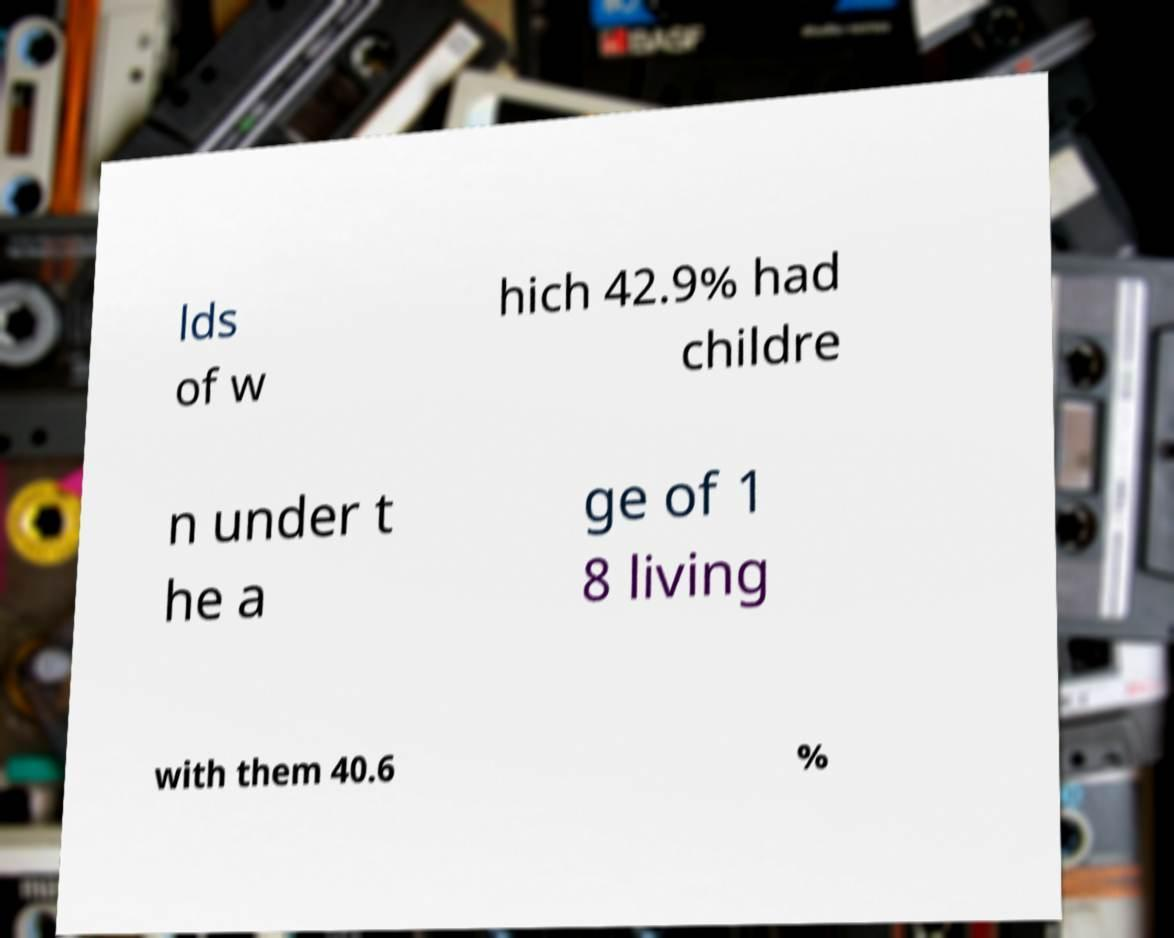Please identify and transcribe the text found in this image. lds of w hich 42.9% had childre n under t he a ge of 1 8 living with them 40.6 % 